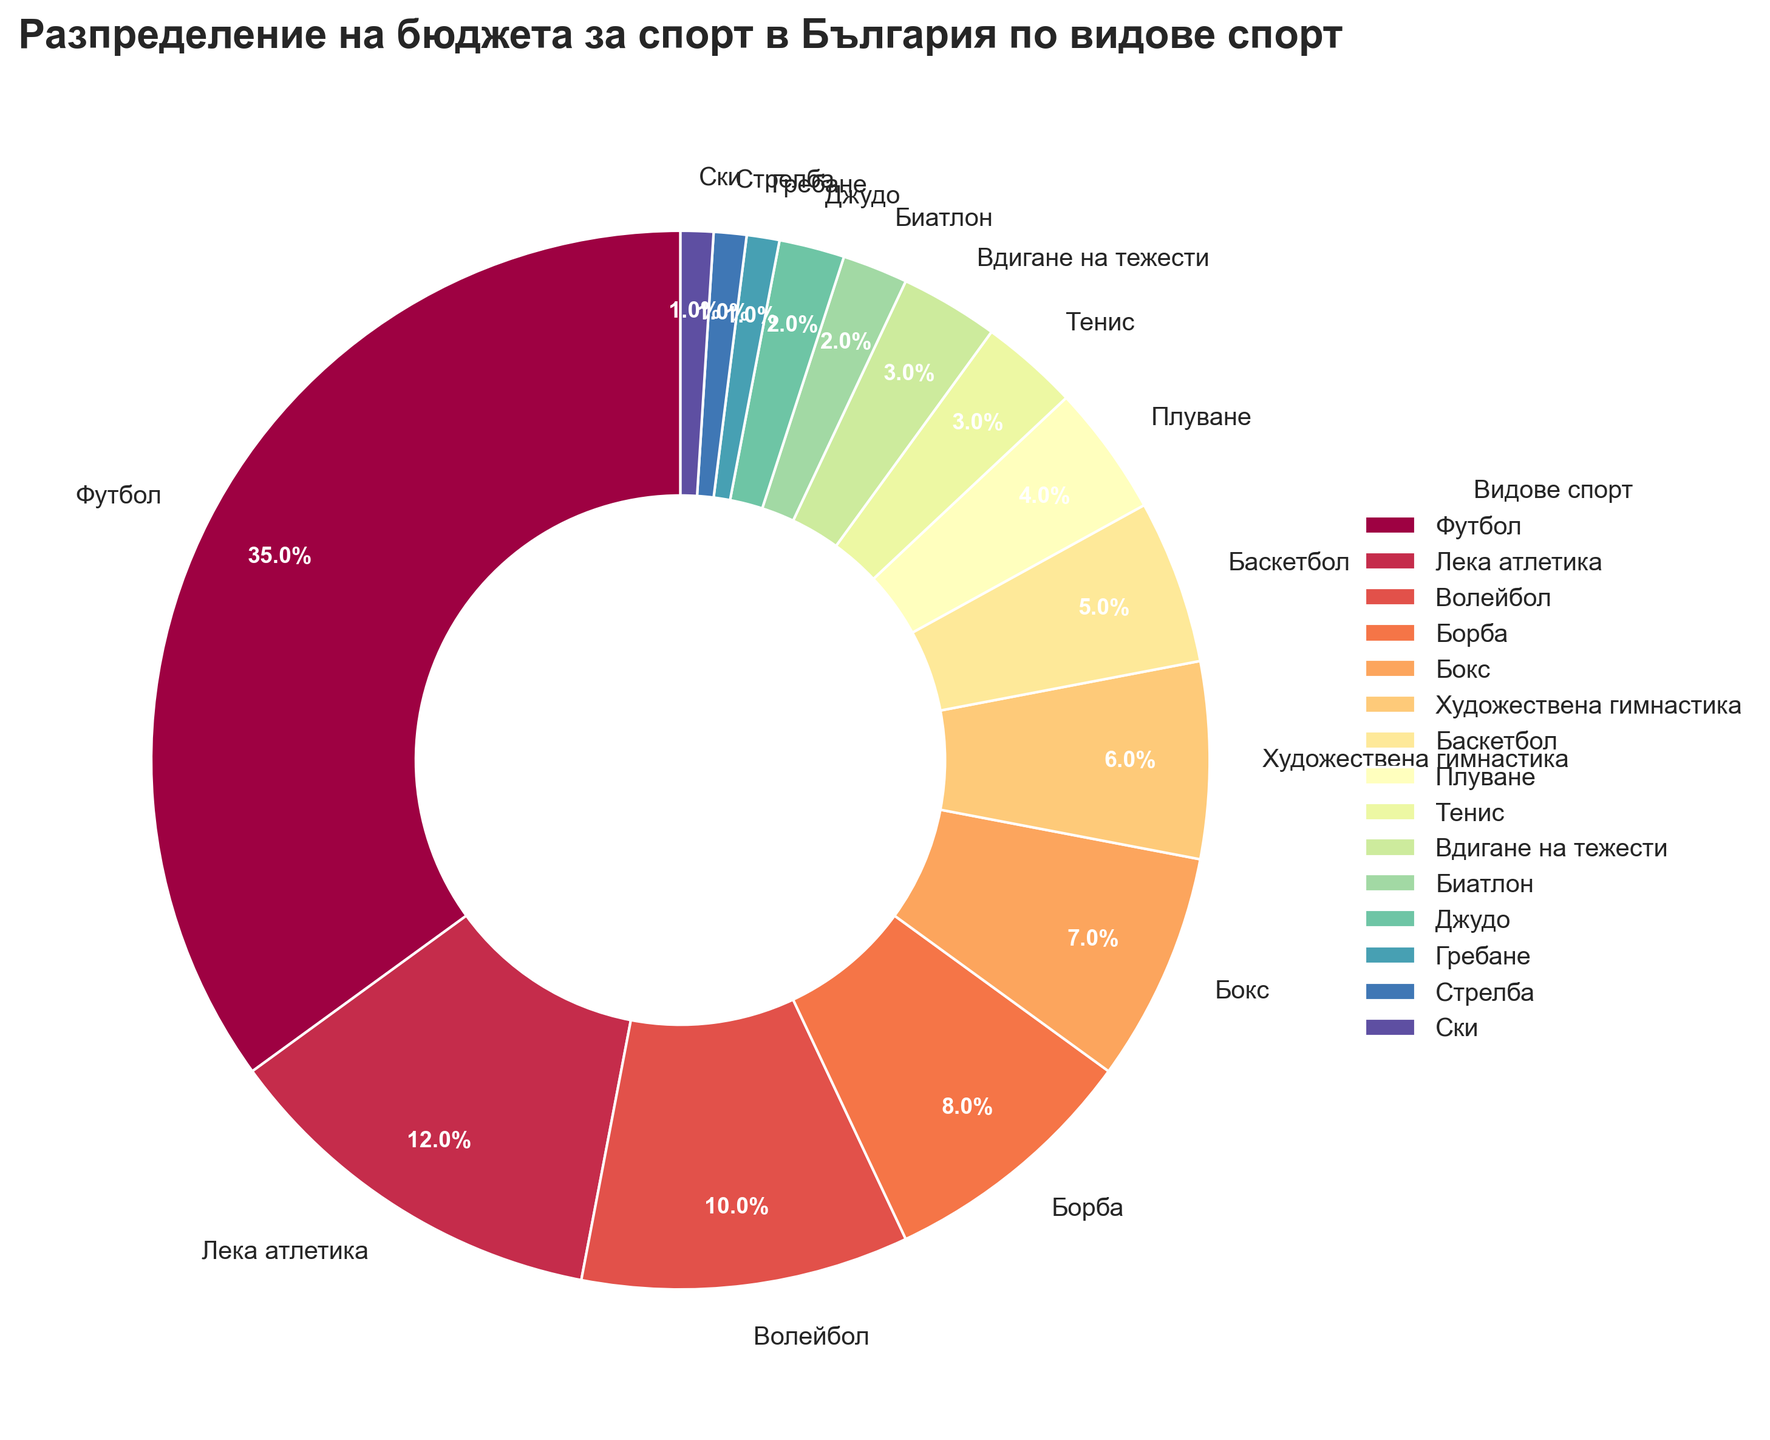Какъв процент от бюджета за спорт се отделя за футбола? Поглеждаме процентите на отделните спортове в диаграмата и виждаме, че футболът е с 35%.
Answer: 35% Кои три спорта заедно съставляват най-малък процент от бюджета? Трябва да намерим трите спорта с най-малки проценти. Вдигане на тежести, биатлон, джудо, гребане, стрелба и ски са спортове с най-малки проценти. Гребане, стрелба и ски са с по 1%.
Answer: Гребане, стрелба, ски Кой спорт получава повече бюджет - бокс или художествена гимнастика? Сравняваме процентите на бокса и художествената гимнастика. Боксът има 7%, а художествената гимнастика има 6%. Значи боксът получава повече.
Answer: бокс Какъв е общият процент от бюджета за спорт, отделян за борба и плуване взети заедно? Събираме процентите за борба (8%) и плуване (4%). 8% + 4% = 12%.
Answer: 12% Кои спортове получават 2% от бюджета? Търсим спортовете с 2% на диаграмата. Биатлон и джудо получават по 2%.
Answer: Биатлон, джудо Кой спорт получава повече бюджет - волейбол или баскетбол? Сравняваме процентите на волейбол (10%) и баскетбол (5%), като волейболът получава повече.
Answer: волейбол Какъв е общият процент от бюджета за спорт, отделян за тенис и вдигане на тежести? Събираме процентите за тенис (3%) и вдигане на тежести (3%). 3% + 3% = 6%.
Answer: 6% Колко спортове имат бюджет по-нисък от 5%? Преглеждаме диаграмата и броим спортовете с процент по-нисък от 5%: плуване, тенис, вдигане на тежести, биатлон, джудо, гребане, стрелба и ски - всичко 8 спорта.
Answer: 8 Кой спорт получава най-висок процент от бюджета? Проверяваме процентите на диаграмата и спортът с най-голям процент е футболът с 35%.
Answer: футбол Колко спортове получават по-нисък процент от бюджета от тениса? Търсим спортовете с по-малък процент от тениса (3%) и те са: биатлон (2%), джудо (2%), гребане (1%), стрелба (1%), ски (1%). Това са 5 спорта.
Answer: 5 